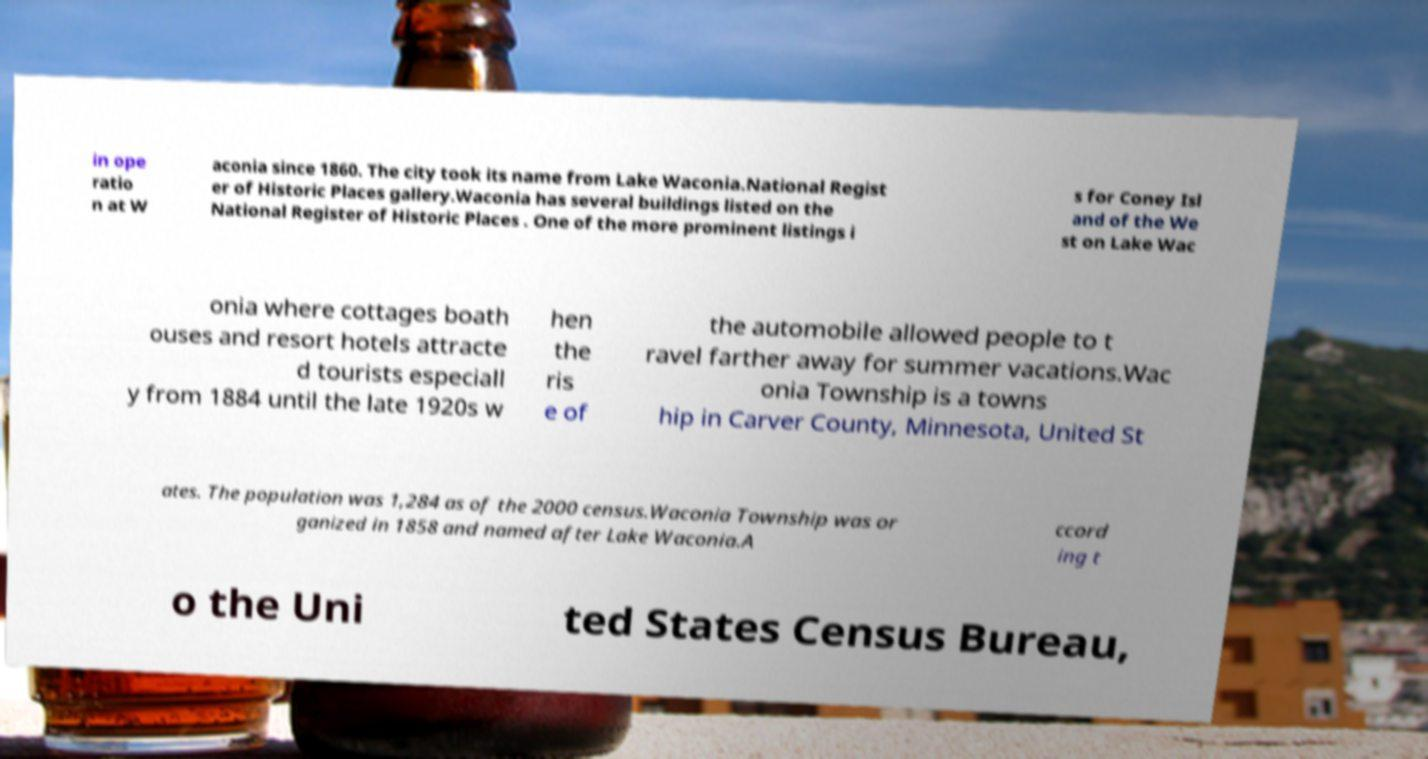For documentation purposes, I need the text within this image transcribed. Could you provide that? in ope ratio n at W aconia since 1860. The city took its name from Lake Waconia.National Regist er of Historic Places gallery.Waconia has several buildings listed on the National Register of Historic Places . One of the more prominent listings i s for Coney Isl and of the We st on Lake Wac onia where cottages boath ouses and resort hotels attracte d tourists especiall y from 1884 until the late 1920s w hen the ris e of the automobile allowed people to t ravel farther away for summer vacations.Wac onia Township is a towns hip in Carver County, Minnesota, United St ates. The population was 1,284 as of the 2000 census.Waconia Township was or ganized in 1858 and named after Lake Waconia.A ccord ing t o the Uni ted States Census Bureau, 